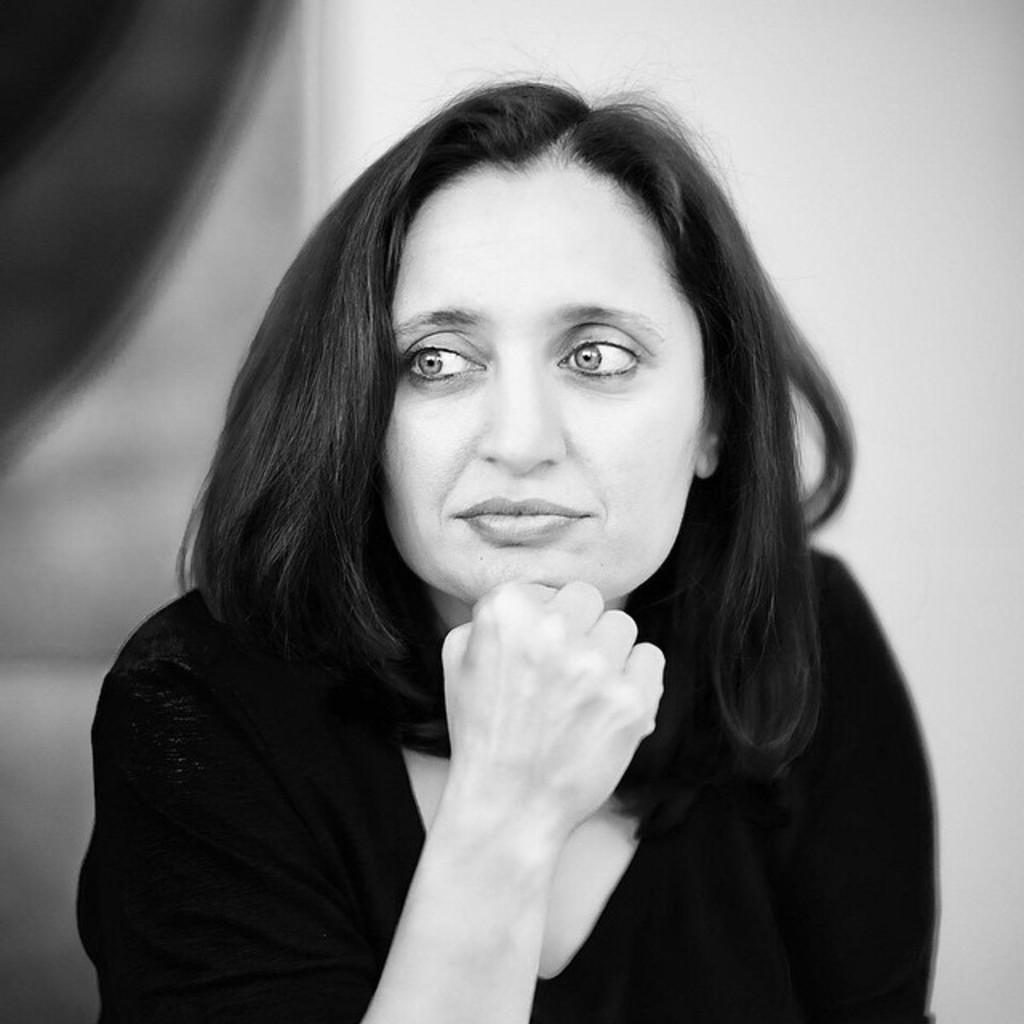What is the color scheme of the image? The image is black and white. Who is the main subject in the image? There is a lady in the center of the image. What can be seen in the background of the image? There is a wall in the background of the image. What type of knot is the lady tying in the image? There is no knot present in the image; the lady is not performing any action involving a knot. 